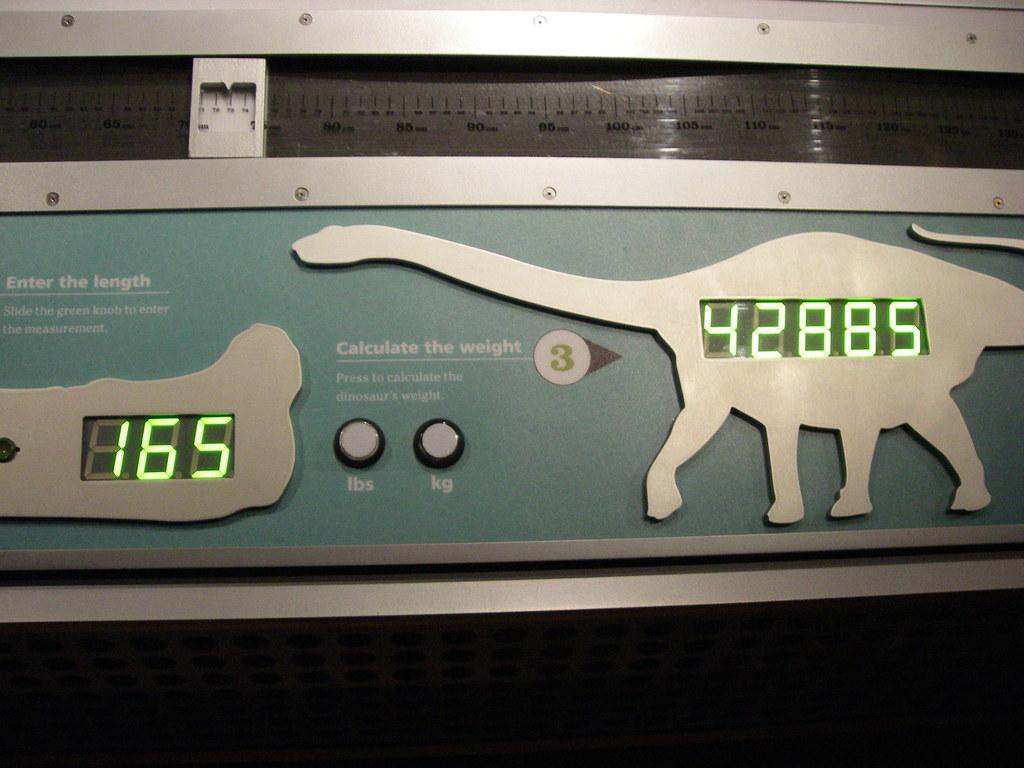What type of device is shown in the image? The device is a weight calculating device. What is the primary function of this device? The primary function of this device is to calculate weight. How many rabbits can be seen swimming with a glove in the image? There are no rabbits or gloves present in the image; it features a weight calculating device. Can you tell me how many goldfish are swimming in the device? The image does not show any goldfish; it is a weight calculating device. 